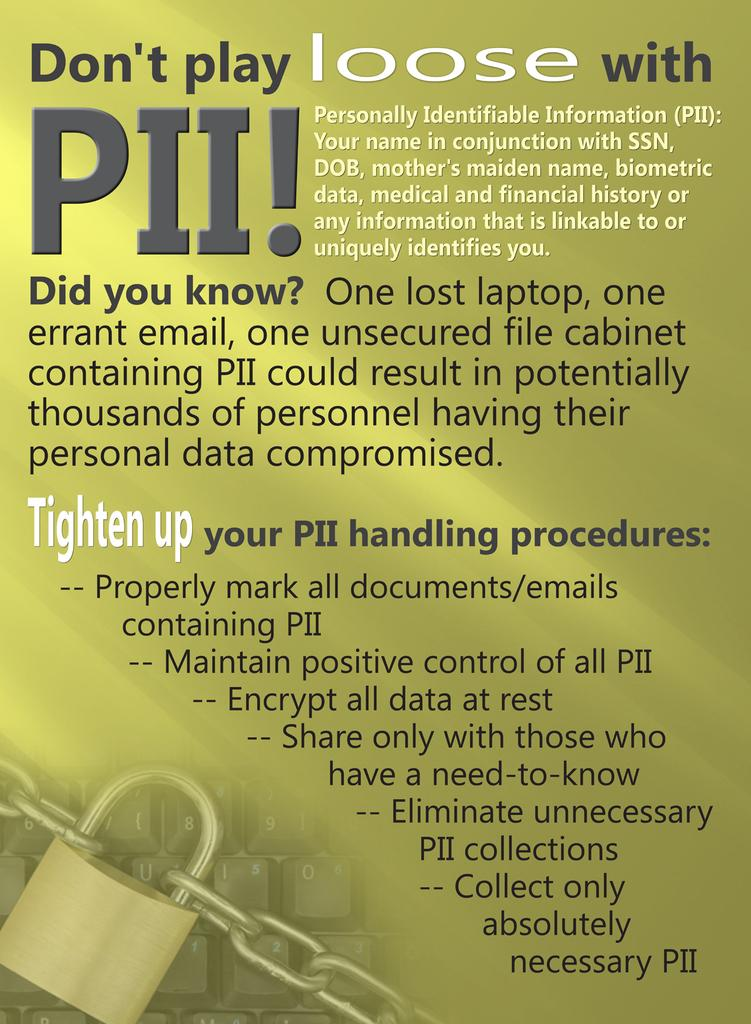<image>
Offer a succinct explanation of the picture presented. A brochure with the topic showing Don't play loose with PII! 